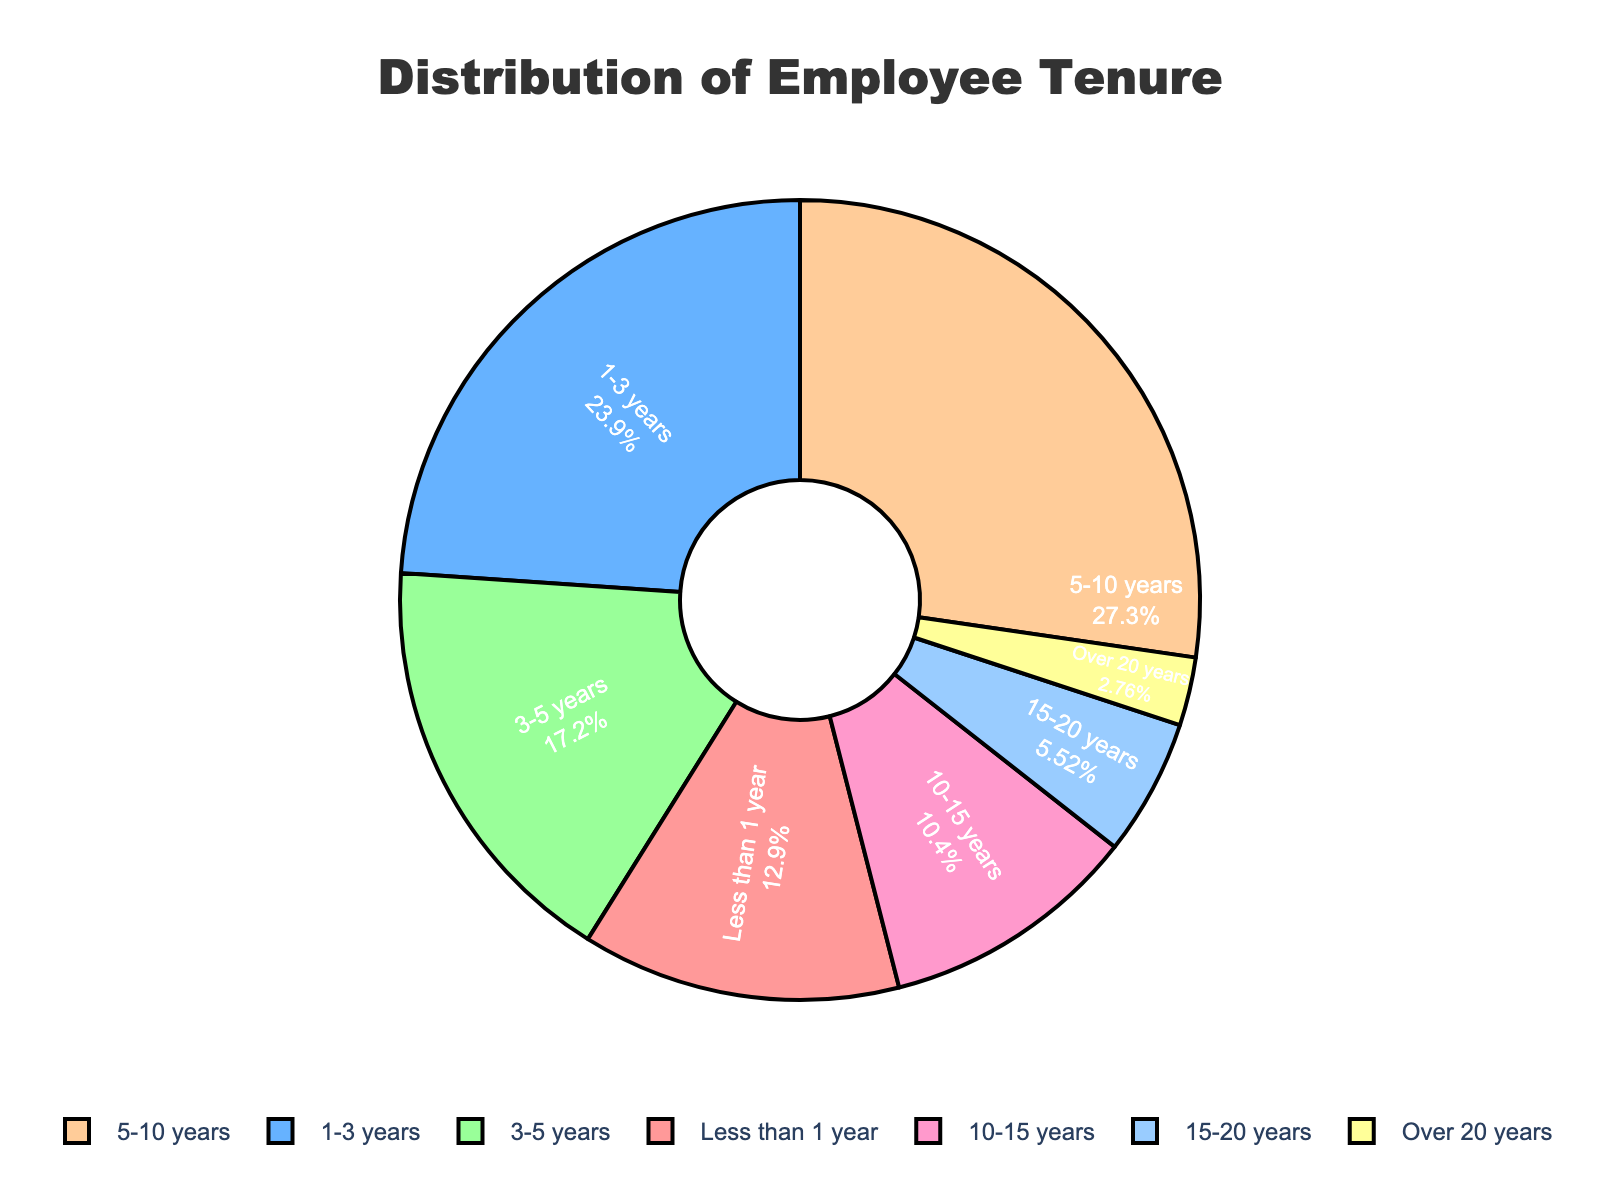What percentage of employees have a tenure of less than 1 year? The figure displays the percentage for each tenure range directly inside each segment. For the "Less than 1 year" segment, find the corresponding percentage value.
Answer: 15.9% Which tenure range has the highest number of employees? From the figure, the segment with the largest area corresponds to the range with the highest number of employees. Check the labels to identify the range.
Answer: 5-10 years How does the number of employees with 10-15 years tenure compare to those with 1-3 years? Look at the percentages for both "10-15 years" and "1-3 years" in the figure and compare them. The "1-3 years" segment is larger.
Answer: Fewer Which color represents the employees with over 20 years of tenure? Match the color of the smallest segment to the corresponding label. The smallest segment accounts for the "Over 20 years" tenure range.
Answer: Yellow What is the combined percentage of employees with 3-5 years and 5-10 years of tenure? Sum the percentages shown for the "3-5 years" and "5-10 years" tenure ranges.
Answer: 41.8% Is the number of employees with 15-20 years of tenure greater than, less than, or equal to those with less than 1 year? Compare the percentages for "15-20 years" and "Less than 1 year" segments. The "Less than 1 year" segment is larger.
Answer: Less than What is the combined percentage of employees with a tenure of over 10 years (sum of 10-15 years, 15-20 years, and over 20 years)? Add the percentages for the "10-15 years," "15-20 years," and "Over 20 years" segments respectively.
Answer: 21.4% 